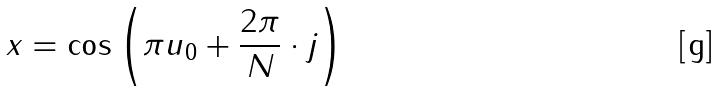<formula> <loc_0><loc_0><loc_500><loc_500>x = \cos \left ( \pi u _ { 0 } + \frac { 2 \pi } { N } \cdot j \right )</formula> 